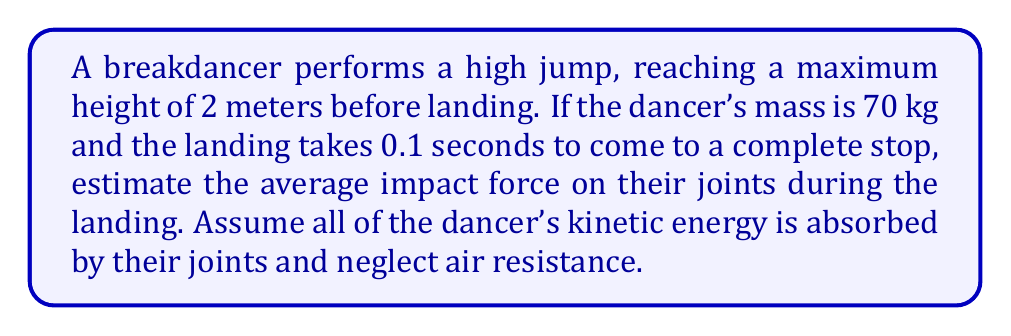Teach me how to tackle this problem. To solve this problem, we'll use the principles of conservation of energy and Newton's Second Law. Let's break it down step-by-step:

1) First, calculate the velocity of the dancer just before landing:
   Using the equation $v^2 = 2gh$, where $g = 9.8 m/s^2$ and $h = 2 m$
   $$v = \sqrt{2gh} = \sqrt{2 \cdot 9.8 \cdot 2} = 6.26 m/s$$

2) Calculate the kinetic energy of the dancer just before landing:
   $$KE = \frac{1}{2}mv^2 = \frac{1}{2} \cdot 70 \cdot 6.26^2 = 1371.7 J$$

3) This kinetic energy is converted to work done by the impact force:
   $$W = F \cdot d$$
   Where $d$ is the stopping distance. We don't know this, but we can use the time given.

4) Use the equation of motion $s = ut + \frac{1}{2}at^2$
   Initial velocity $u = 6.26 m/s$, final velocity $v = 0$, time $t = 0.1 s$
   $$0 = 6.26 \cdot 0.1 + \frac{1}{2}a \cdot 0.1^2$$
   $$a = -626 m/s^2$$

5) Now we can find the stopping distance:
   $$d = ut + \frac{1}{2}at^2 = 6.26 \cdot 0.1 + \frac{1}{2} \cdot (-626) \cdot 0.1^2 = 0.313 m$$

6) Using Work-Energy theorem:
   $$F \cdot 0.313 = 1371.7$$
   $$F = 4382.7 N$$

7) We can verify this using $F = ma$:
   $$F = 70 \cdot 626 = 4382 N$$

Therefore, the average impact force on the joints during landing is approximately 4383 N.
Answer: 4383 N 